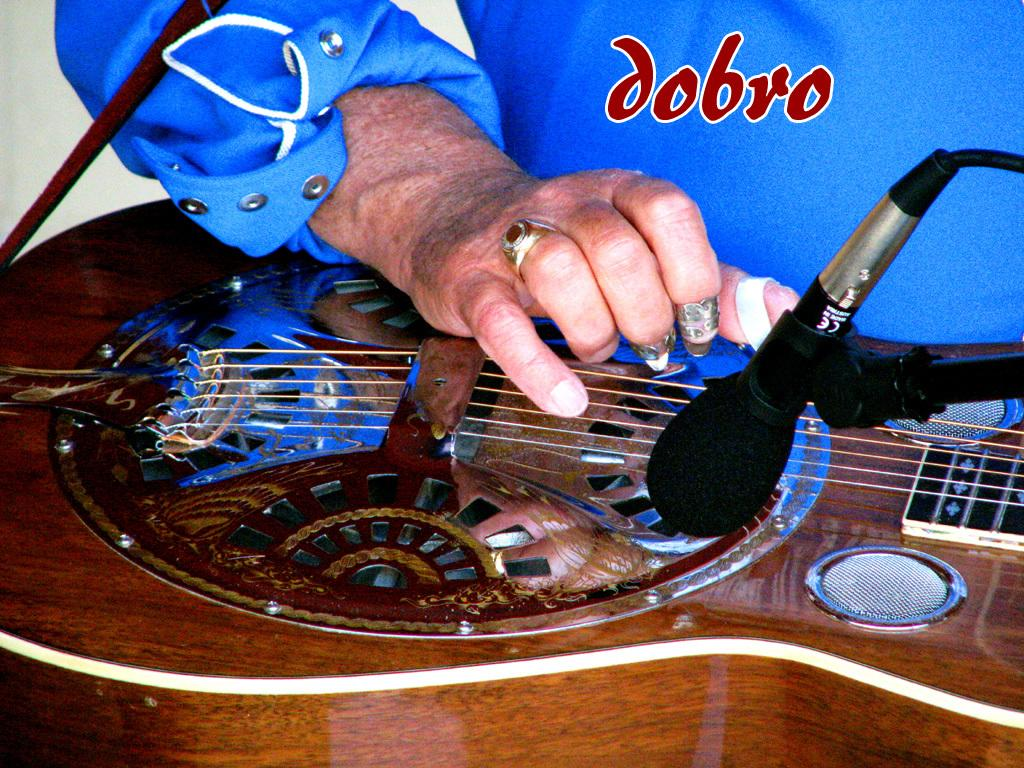What is the person in the image doing? The person is playing a guitar. How is the person playing the guitar? The person is using their fingers to play the play the guitar. What other object can be seen in the image? There is a microphone (mike) in the image. What type of gate can be seen in the image? There is no gate present in the image; it features a person playing a guitar and a microphone. Is there a bomb visible in the image? No, there is no bomb present in the image. 